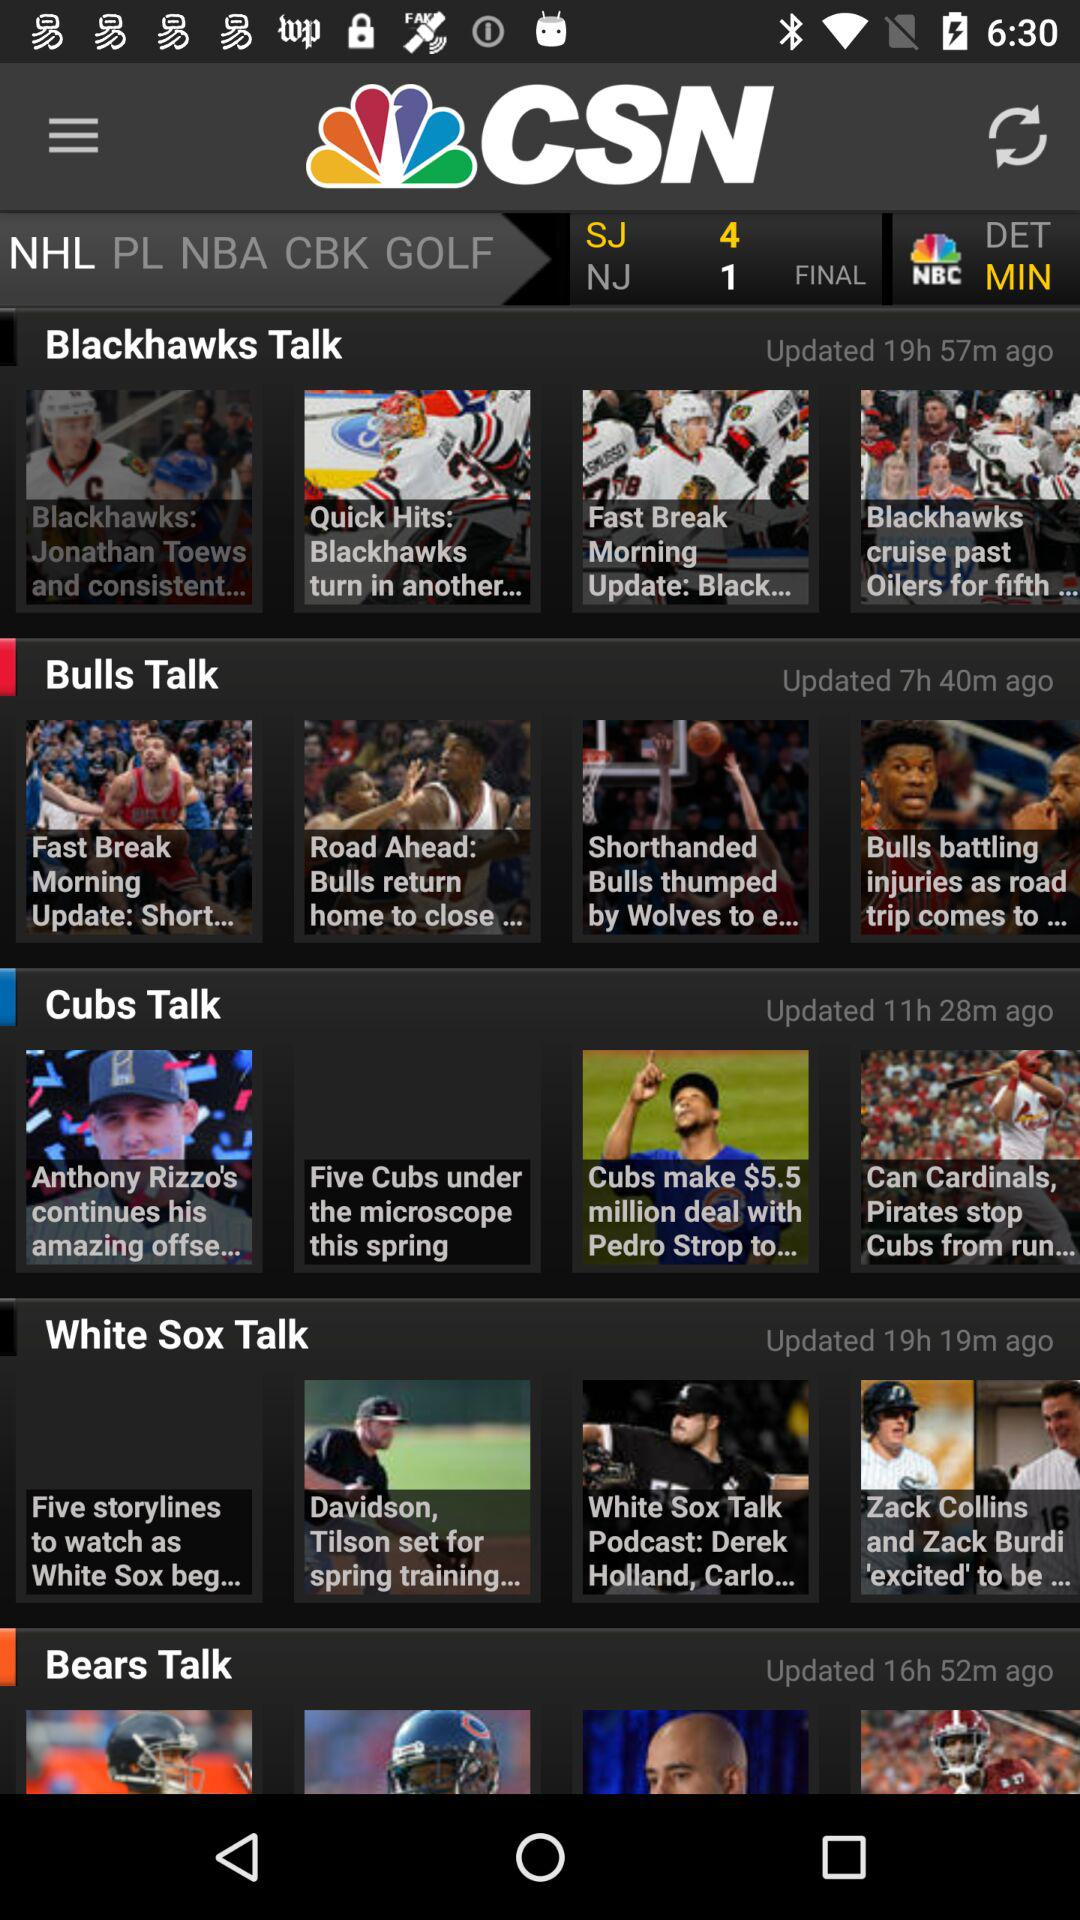What's the final score between the "SJ and NJ match"? The scores are SF: 4 and NJ: 1. 